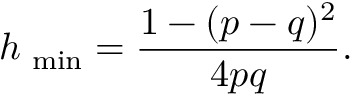Convert formula to latex. <formula><loc_0><loc_0><loc_500><loc_500>h _ { \min } = \frac { 1 - ( p - q ) ^ { 2 } } { 4 p q } .</formula> 